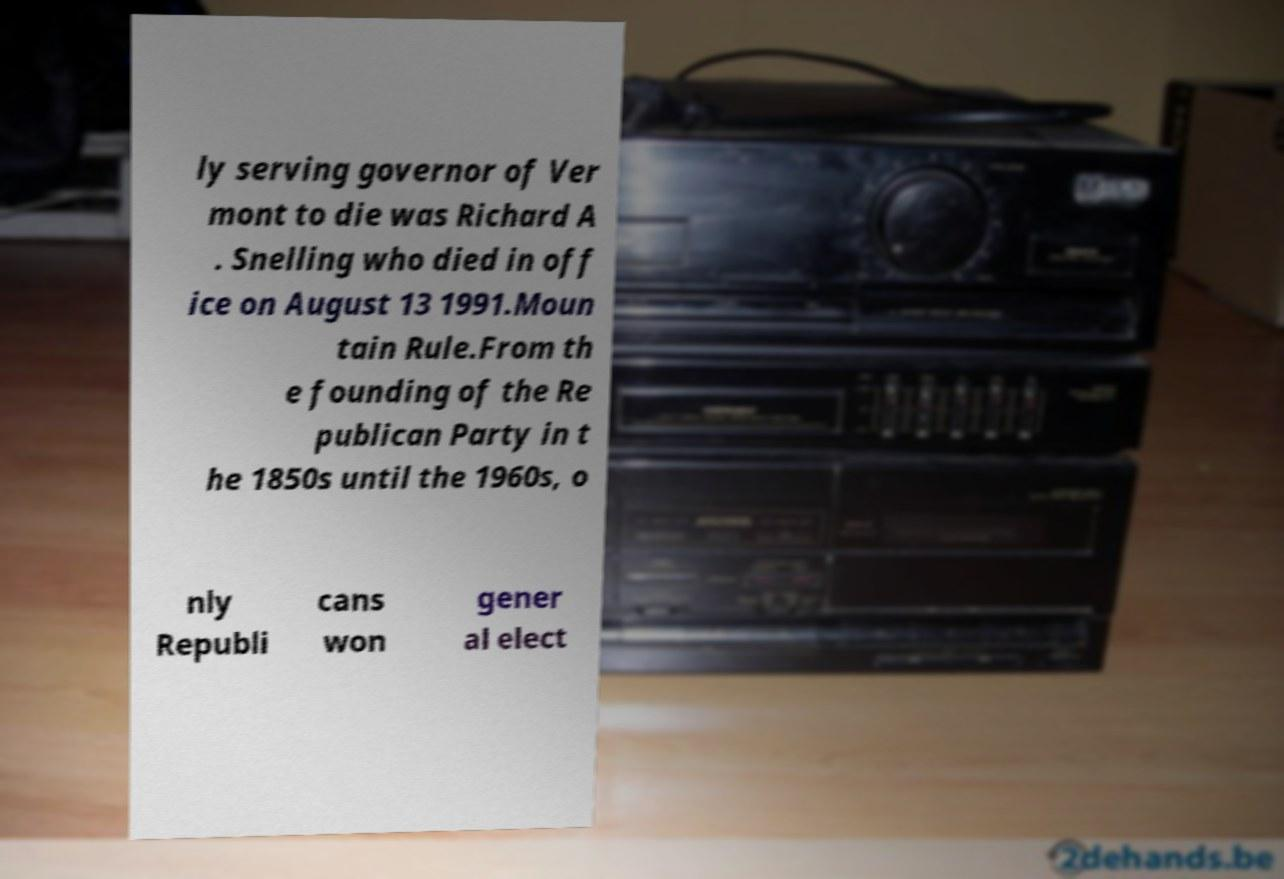Please identify and transcribe the text found in this image. ly serving governor of Ver mont to die was Richard A . Snelling who died in off ice on August 13 1991.Moun tain Rule.From th e founding of the Re publican Party in t he 1850s until the 1960s, o nly Republi cans won gener al elect 